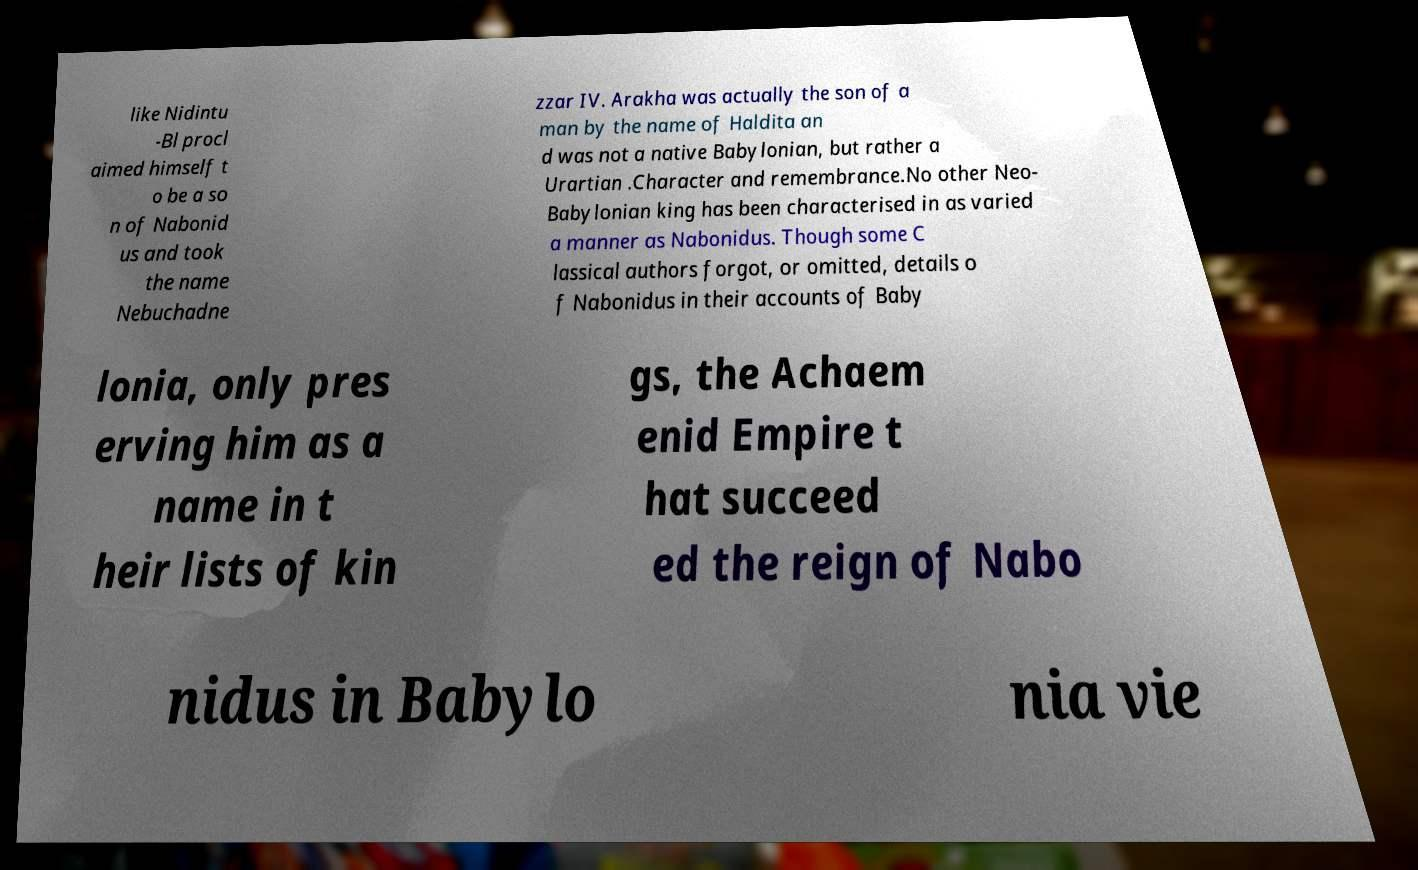There's text embedded in this image that I need extracted. Can you transcribe it verbatim? like Nidintu -Bl procl aimed himself t o be a so n of Nabonid us and took the name Nebuchadne zzar IV. Arakha was actually the son of a man by the name of Haldita an d was not a native Babylonian, but rather a Urartian .Character and remembrance.No other Neo- Babylonian king has been characterised in as varied a manner as Nabonidus. Though some C lassical authors forgot, or omitted, details o f Nabonidus in their accounts of Baby lonia, only pres erving him as a name in t heir lists of kin gs, the Achaem enid Empire t hat succeed ed the reign of Nabo nidus in Babylo nia vie 